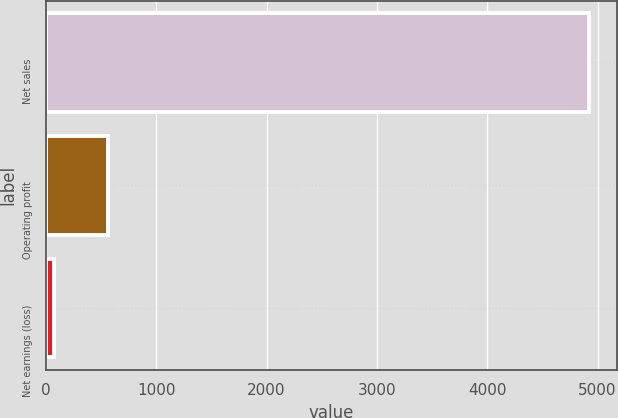Convert chart. <chart><loc_0><loc_0><loc_500><loc_500><bar_chart><fcel>Net sales<fcel>Operating profit<fcel>Net earnings (loss)<nl><fcel>4927<fcel>561.1<fcel>76<nl></chart> 